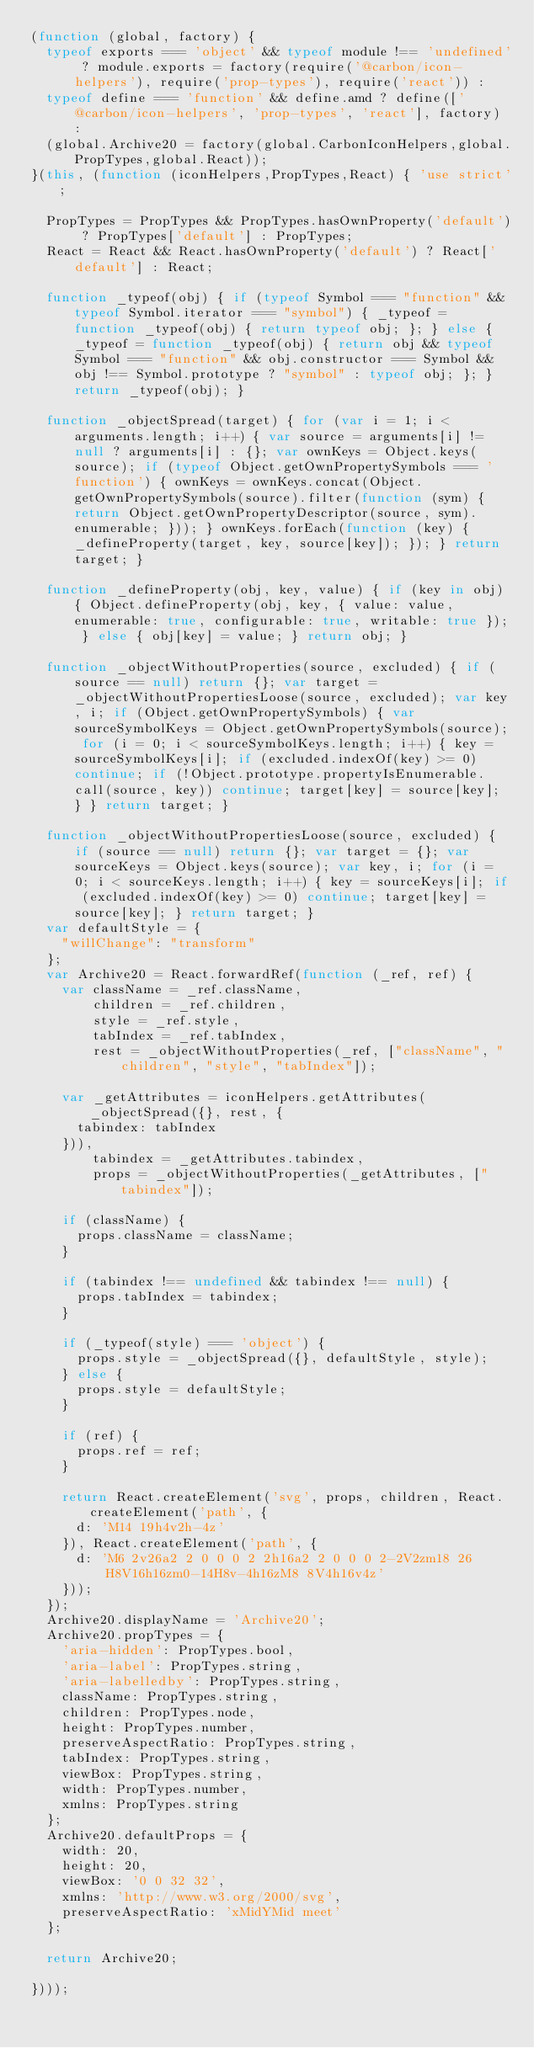Convert code to text. <code><loc_0><loc_0><loc_500><loc_500><_JavaScript_>(function (global, factory) {
  typeof exports === 'object' && typeof module !== 'undefined' ? module.exports = factory(require('@carbon/icon-helpers'), require('prop-types'), require('react')) :
  typeof define === 'function' && define.amd ? define(['@carbon/icon-helpers', 'prop-types', 'react'], factory) :
  (global.Archive20 = factory(global.CarbonIconHelpers,global.PropTypes,global.React));
}(this, (function (iconHelpers,PropTypes,React) { 'use strict';

  PropTypes = PropTypes && PropTypes.hasOwnProperty('default') ? PropTypes['default'] : PropTypes;
  React = React && React.hasOwnProperty('default') ? React['default'] : React;

  function _typeof(obj) { if (typeof Symbol === "function" && typeof Symbol.iterator === "symbol") { _typeof = function _typeof(obj) { return typeof obj; }; } else { _typeof = function _typeof(obj) { return obj && typeof Symbol === "function" && obj.constructor === Symbol && obj !== Symbol.prototype ? "symbol" : typeof obj; }; } return _typeof(obj); }

  function _objectSpread(target) { for (var i = 1; i < arguments.length; i++) { var source = arguments[i] != null ? arguments[i] : {}; var ownKeys = Object.keys(source); if (typeof Object.getOwnPropertySymbols === 'function') { ownKeys = ownKeys.concat(Object.getOwnPropertySymbols(source).filter(function (sym) { return Object.getOwnPropertyDescriptor(source, sym).enumerable; })); } ownKeys.forEach(function (key) { _defineProperty(target, key, source[key]); }); } return target; }

  function _defineProperty(obj, key, value) { if (key in obj) { Object.defineProperty(obj, key, { value: value, enumerable: true, configurable: true, writable: true }); } else { obj[key] = value; } return obj; }

  function _objectWithoutProperties(source, excluded) { if (source == null) return {}; var target = _objectWithoutPropertiesLoose(source, excluded); var key, i; if (Object.getOwnPropertySymbols) { var sourceSymbolKeys = Object.getOwnPropertySymbols(source); for (i = 0; i < sourceSymbolKeys.length; i++) { key = sourceSymbolKeys[i]; if (excluded.indexOf(key) >= 0) continue; if (!Object.prototype.propertyIsEnumerable.call(source, key)) continue; target[key] = source[key]; } } return target; }

  function _objectWithoutPropertiesLoose(source, excluded) { if (source == null) return {}; var target = {}; var sourceKeys = Object.keys(source); var key, i; for (i = 0; i < sourceKeys.length; i++) { key = sourceKeys[i]; if (excluded.indexOf(key) >= 0) continue; target[key] = source[key]; } return target; }
  var defaultStyle = {
    "willChange": "transform"
  };
  var Archive20 = React.forwardRef(function (_ref, ref) {
    var className = _ref.className,
        children = _ref.children,
        style = _ref.style,
        tabIndex = _ref.tabIndex,
        rest = _objectWithoutProperties(_ref, ["className", "children", "style", "tabIndex"]);

    var _getAttributes = iconHelpers.getAttributes(_objectSpread({}, rest, {
      tabindex: tabIndex
    })),
        tabindex = _getAttributes.tabindex,
        props = _objectWithoutProperties(_getAttributes, ["tabindex"]);

    if (className) {
      props.className = className;
    }

    if (tabindex !== undefined && tabindex !== null) {
      props.tabIndex = tabindex;
    }

    if (_typeof(style) === 'object') {
      props.style = _objectSpread({}, defaultStyle, style);
    } else {
      props.style = defaultStyle;
    }

    if (ref) {
      props.ref = ref;
    }

    return React.createElement('svg', props, children, React.createElement('path', {
      d: 'M14 19h4v2h-4z'
    }), React.createElement('path', {
      d: 'M6 2v26a2 2 0 0 0 2 2h16a2 2 0 0 0 2-2V2zm18 26H8V16h16zm0-14H8v-4h16zM8 8V4h16v4z'
    }));
  });
  Archive20.displayName = 'Archive20';
  Archive20.propTypes = {
    'aria-hidden': PropTypes.bool,
    'aria-label': PropTypes.string,
    'aria-labelledby': PropTypes.string,
    className: PropTypes.string,
    children: PropTypes.node,
    height: PropTypes.number,
    preserveAspectRatio: PropTypes.string,
    tabIndex: PropTypes.string,
    viewBox: PropTypes.string,
    width: PropTypes.number,
    xmlns: PropTypes.string
  };
  Archive20.defaultProps = {
    width: 20,
    height: 20,
    viewBox: '0 0 32 32',
    xmlns: 'http://www.w3.org/2000/svg',
    preserveAspectRatio: 'xMidYMid meet'
  };

  return Archive20;

})));
</code> 